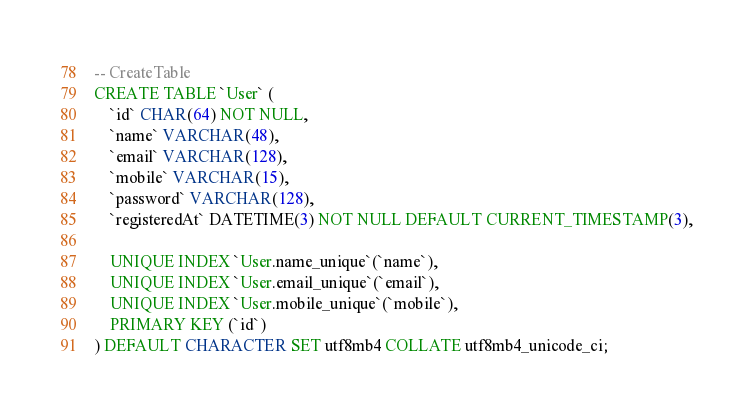<code> <loc_0><loc_0><loc_500><loc_500><_SQL_>-- CreateTable
CREATE TABLE `User` (
    `id` CHAR(64) NOT NULL,
    `name` VARCHAR(48),
    `email` VARCHAR(128),
    `mobile` VARCHAR(15),
    `password` VARCHAR(128),
    `registeredAt` DATETIME(3) NOT NULL DEFAULT CURRENT_TIMESTAMP(3),

    UNIQUE INDEX `User.name_unique`(`name`),
    UNIQUE INDEX `User.email_unique`(`email`),
    UNIQUE INDEX `User.mobile_unique`(`mobile`),
    PRIMARY KEY (`id`)
) DEFAULT CHARACTER SET utf8mb4 COLLATE utf8mb4_unicode_ci;
</code> 